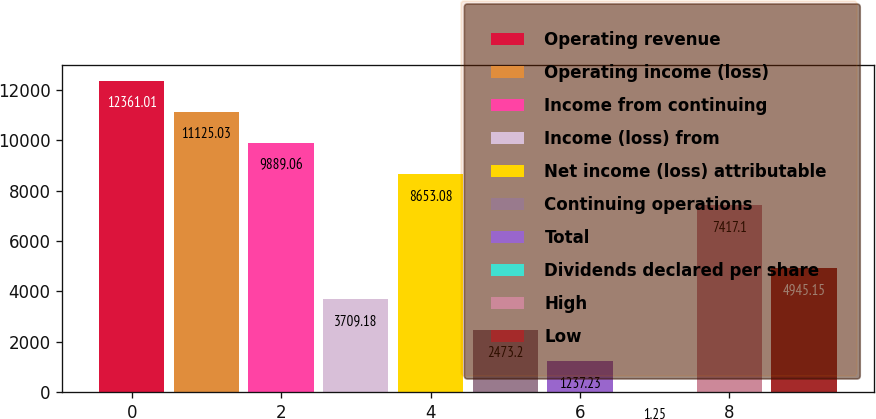Convert chart to OTSL. <chart><loc_0><loc_0><loc_500><loc_500><bar_chart><fcel>Operating revenue<fcel>Operating income (loss)<fcel>Income from continuing<fcel>Income (loss) from<fcel>Net income (loss) attributable<fcel>Continuing operations<fcel>Total<fcel>Dividends declared per share<fcel>High<fcel>Low<nl><fcel>12361<fcel>11125<fcel>9889.06<fcel>3709.18<fcel>8653.08<fcel>2473.2<fcel>1237.23<fcel>1.25<fcel>7417.1<fcel>4945.15<nl></chart> 